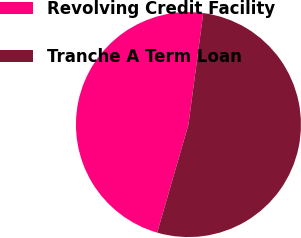Convert chart. <chart><loc_0><loc_0><loc_500><loc_500><pie_chart><fcel>Revolving Credit Facility<fcel>Tranche A Term Loan<nl><fcel>47.62%<fcel>52.38%<nl></chart> 